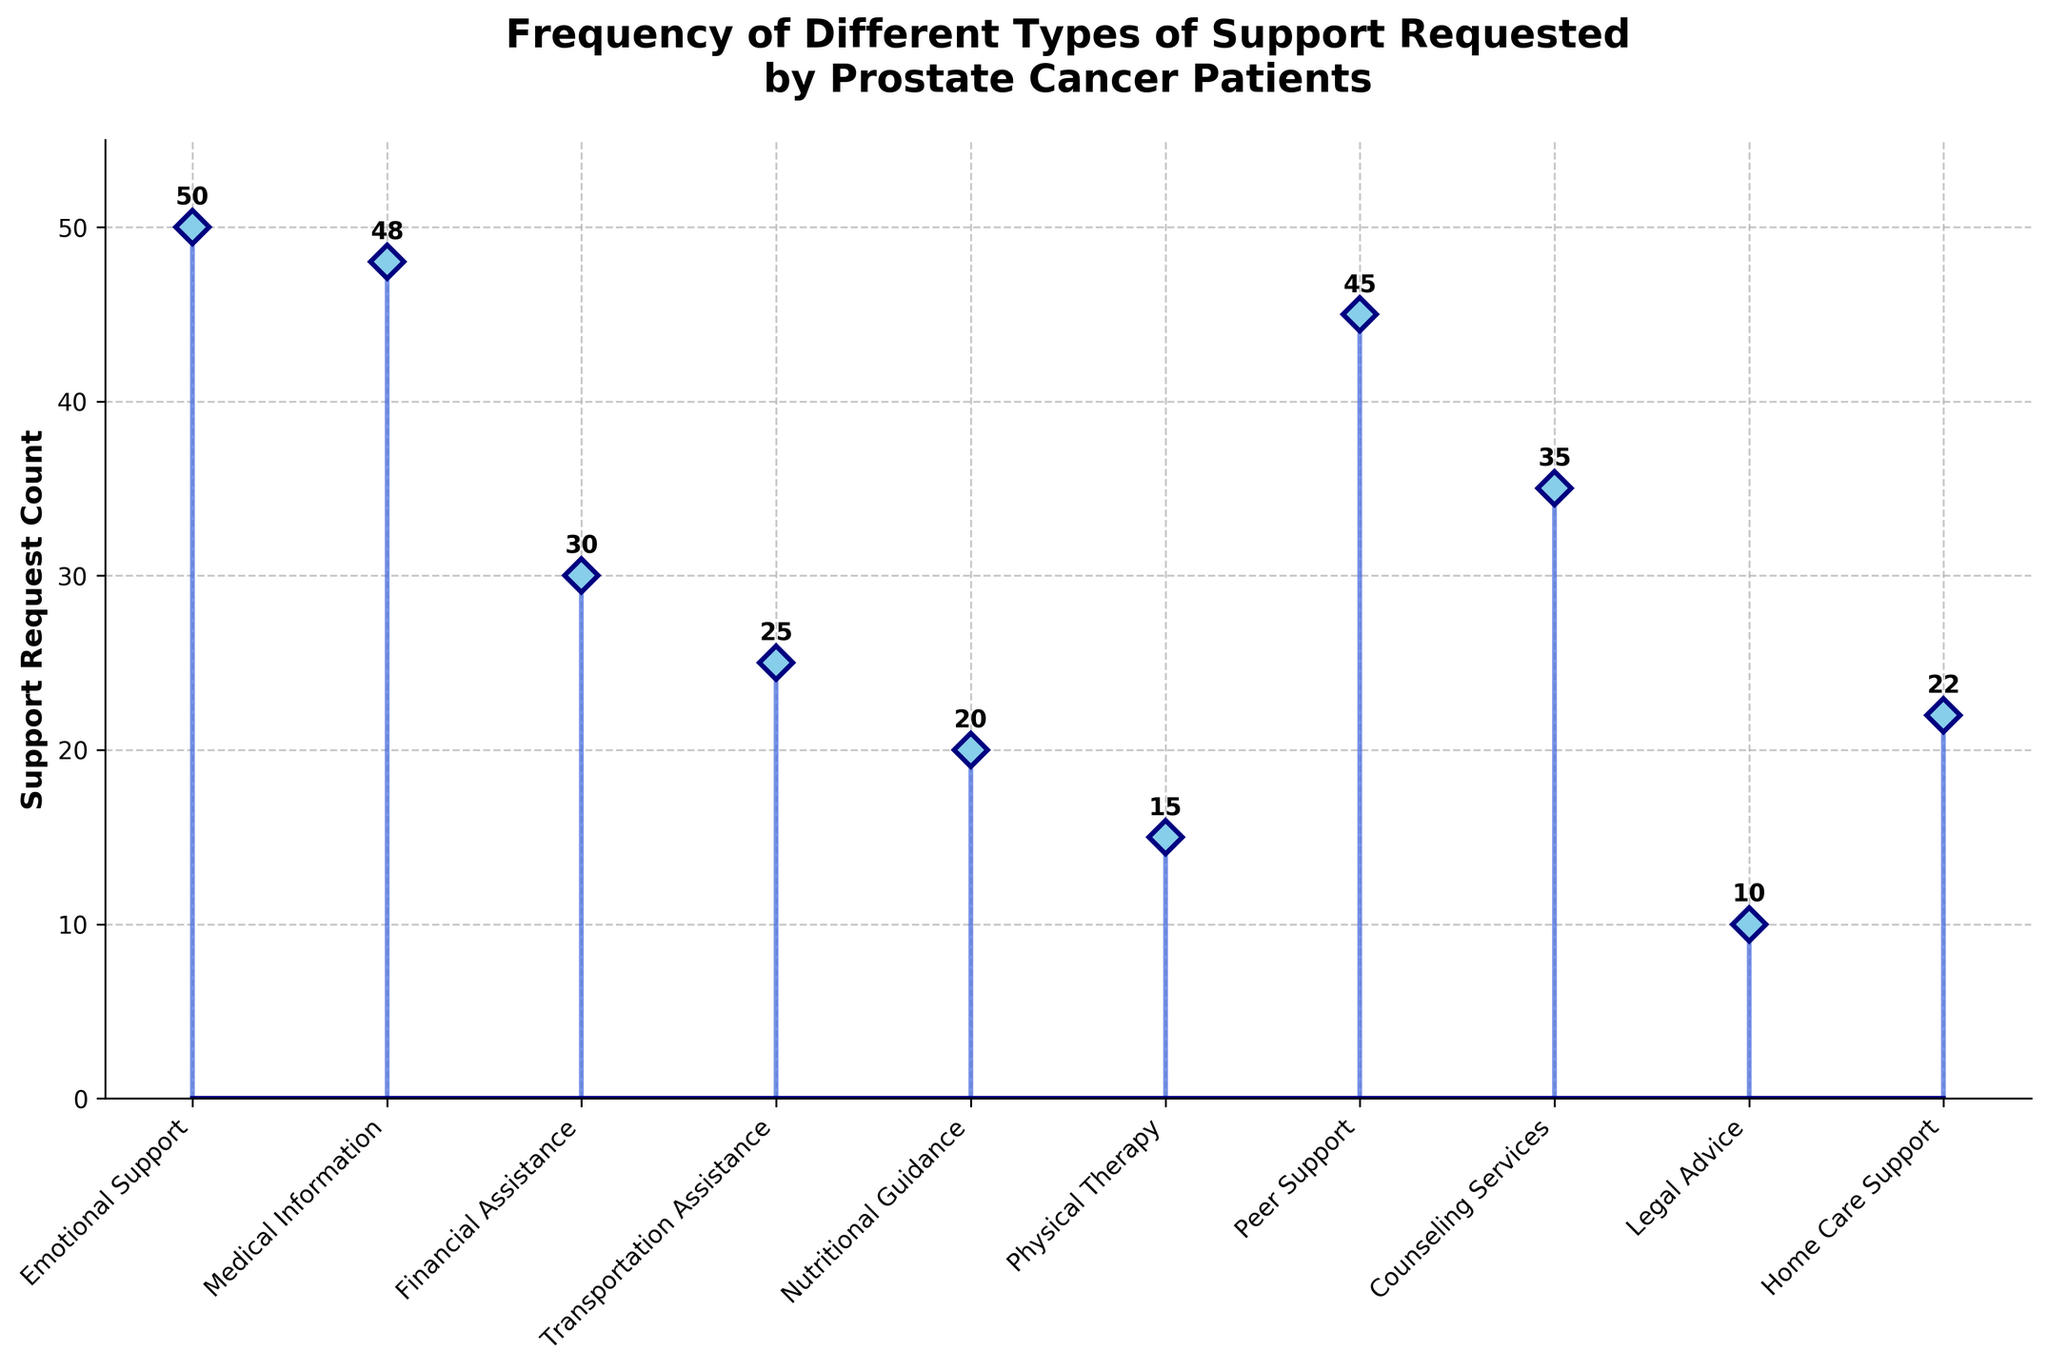What is the title of the plot? The title is located at the top of the figure and describes the subject of the plot. The title reads "Frequency of Different Types of Support Requested by Prostate Cancer Patients"
Answer: Frequency of Different Types of Support Requested by Prostate Cancer Patients Which type of support has the highest number of requests? Looking at the stems, the longest stem corresponds to "Emotional Support" with a height of 50 requests.
Answer: Emotional Support How many more requests are there for Emotional Support compared to Legal Advice? Emotional Support has 50 requests, and Legal Advice has 10 requests. The difference is 50 - 10 = 40.
Answer: 40 What is the sum of the requests for Peer Support and Counseling Services? Peer Support has 45 requests, and Counseling Services has 35 requests. The sum is 45 + 35 = 80.
Answer: 80 Which types of support have fewer than 20 requests? The types of support that have fewer than 20 requests are those with stems shorter than the "20" mark: Legal Advice (10), Physical Therapy (15).
Answer: Legal Advice, Physical Therapy How many types of support have more than 30 requests? By counting the types of support with stems taller than the "30" mark, we find Emotional Support (50), Medical Information (48), Peer Support (45), and Counseling Services (35).
Answer: 4 What is the difference between the number of requests for Medical Information and Home Care Support? Medical Information has 48 requests, and Home Care Support has 22 requests. The difference is 48 - 22 = 26.
Answer: 26 Which types of support have the same number of requests? By examining the figure, no two types of support have the exact same number of requests.
Answer: None What's the average number of requests for all the types of support? First, sum all the requests: 50 + 48 + 30 + 25 + 20 + 15 + 45 + 35 + 10 + 22 = 300. There are 10 types of support, so the average is 300 / 10 = 30.
Answer: 30 Which type of support has the second-highest number of requests? The second longest stem corresponds to the second-highest request count. Medical Information has the second-highest number of requests with 48.
Answer: Medical Information 